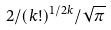<formula> <loc_0><loc_0><loc_500><loc_500>2 / { ( k ! ) } ^ { 1 / 2 k } / \sqrt { \pi }</formula> 